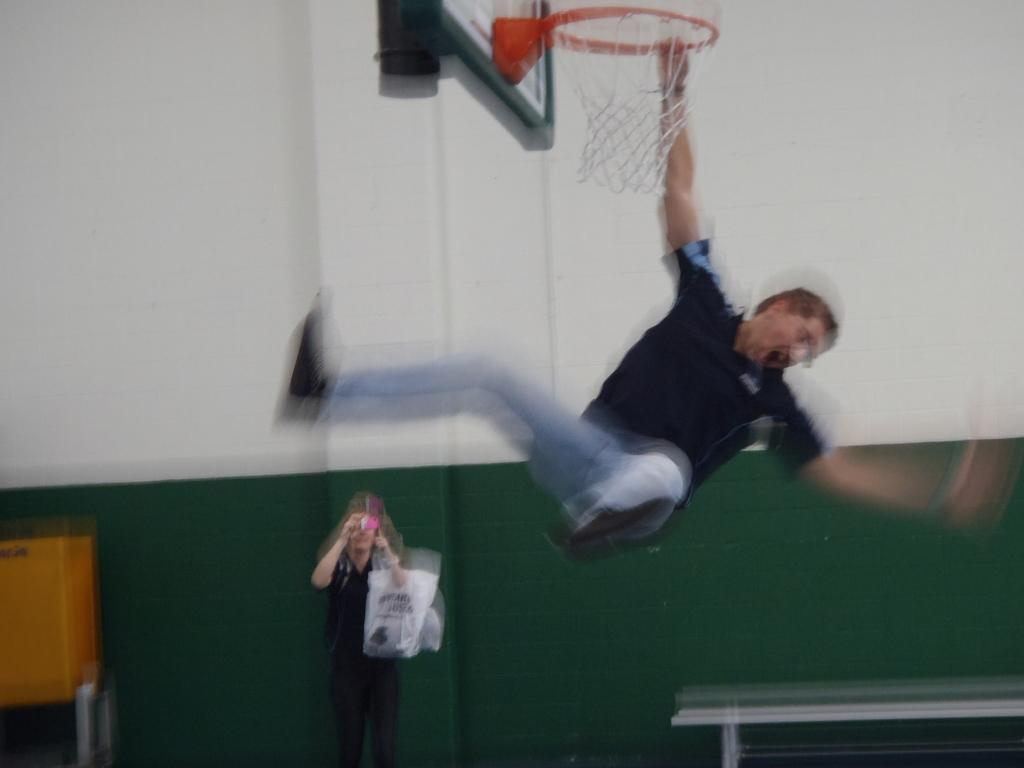What is the man holding in the image? The man is holding a goal post in the image. Can you describe the person standing on the backside? The person is standing on the backside and holding some covers and a device. What type of furniture is present in the image? There is a bench in the image. What other objects can be seen in the image? There is a board and a wall in the image. What type of driving is the man doing in the image? There is no driving activity present in the image; the man is holding a goal post. 